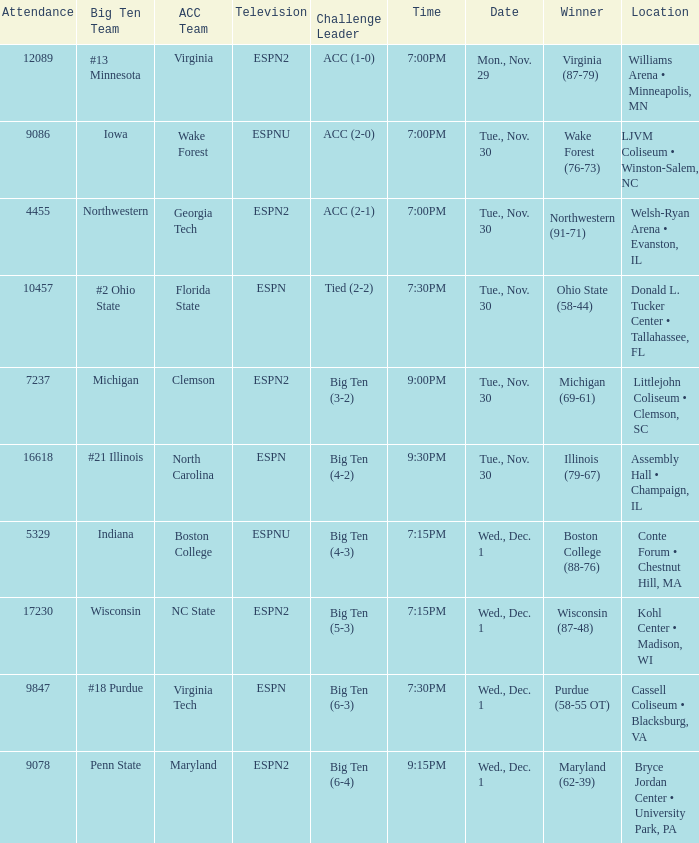Can you parse all the data within this table? {'header': ['Attendance', 'Big Ten Team', 'ACC Team', 'Television', 'Challenge Leader', 'Time', 'Date', 'Winner', 'Location'], 'rows': [['12089', '#13 Minnesota', 'Virginia', 'ESPN2', 'ACC (1-0)', '7:00PM', 'Mon., Nov. 29', 'Virginia (87-79)', 'Williams Arena • Minneapolis, MN'], ['9086', 'Iowa', 'Wake Forest', 'ESPNU', 'ACC (2-0)', '7:00PM', 'Tue., Nov. 30', 'Wake Forest (76-73)', 'LJVM Coliseum • Winston-Salem, NC'], ['4455', 'Northwestern', 'Georgia Tech', 'ESPN2', 'ACC (2-1)', '7:00PM', 'Tue., Nov. 30', 'Northwestern (91-71)', 'Welsh-Ryan Arena • Evanston, IL'], ['10457', '#2 Ohio State', 'Florida State', 'ESPN', 'Tied (2-2)', '7:30PM', 'Tue., Nov. 30', 'Ohio State (58-44)', 'Donald L. Tucker Center • Tallahassee, FL'], ['7237', 'Michigan', 'Clemson', 'ESPN2', 'Big Ten (3-2)', '9:00PM', 'Tue., Nov. 30', 'Michigan (69-61)', 'Littlejohn Coliseum • Clemson, SC'], ['16618', '#21 Illinois', 'North Carolina', 'ESPN', 'Big Ten (4-2)', '9:30PM', 'Tue., Nov. 30', 'Illinois (79-67)', 'Assembly Hall • Champaign, IL'], ['5329', 'Indiana', 'Boston College', 'ESPNU', 'Big Ten (4-3)', '7:15PM', 'Wed., Dec. 1', 'Boston College (88-76)', 'Conte Forum • Chestnut Hill, MA'], ['17230', 'Wisconsin', 'NC State', 'ESPN2', 'Big Ten (5-3)', '7:15PM', 'Wed., Dec. 1', 'Wisconsin (87-48)', 'Kohl Center • Madison, WI'], ['9847', '#18 Purdue', 'Virginia Tech', 'ESPN', 'Big Ten (6-3)', '7:30PM', 'Wed., Dec. 1', 'Purdue (58-55 OT)', 'Cassell Coliseum • Blacksburg, VA'], ['9078', 'Penn State', 'Maryland', 'ESPN2', 'Big Ten (6-4)', '9:15PM', 'Wed., Dec. 1', 'Maryland (62-39)', 'Bryce Jordan Center • University Park, PA']]} What was the time of the games that took place at the cassell coliseum • blacksburg, va? 7:30PM. 